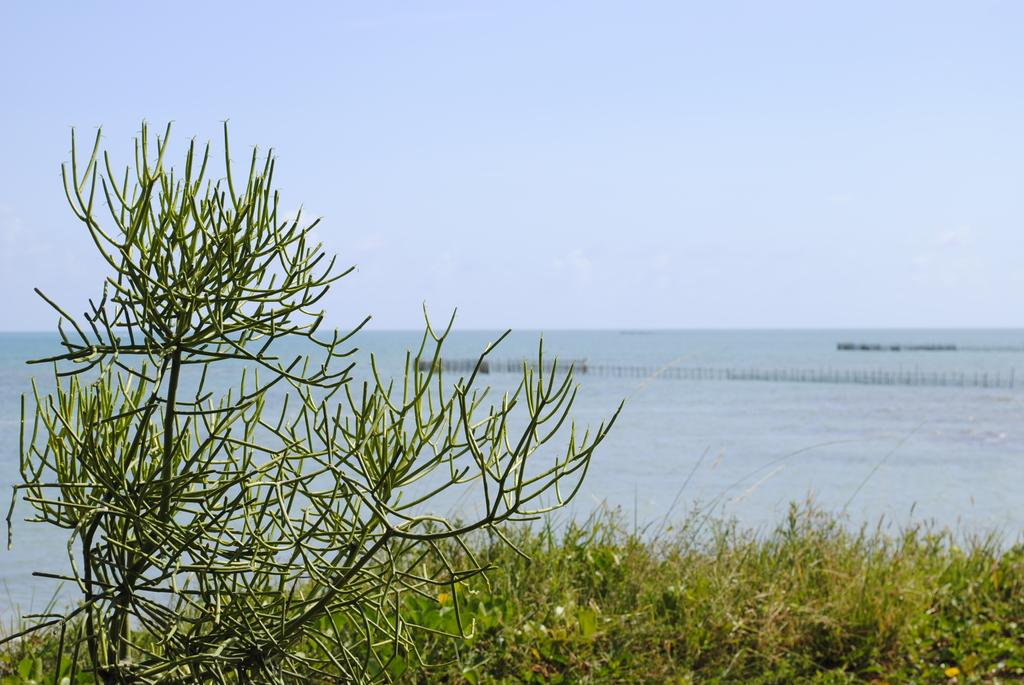What can be seen in the foreground of the image? There are plants and trees in the foreground of the image. What is visible in the background of the image? There is a water body in the background of the image. What structure is present in the image? The image features a bridge. What is the condition of the sky in the image? The sky is clear in the image. Can you see a house in the image? There is no house mentioned or visible in the image. How many bees are buzzing around the plants in the image? There are no bees present in the image; only plants and trees are visible in the foreground. 